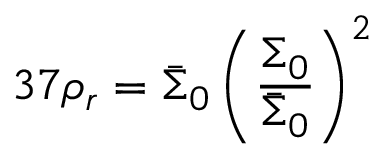Convert formula to latex. <formula><loc_0><loc_0><loc_500><loc_500>3 7 \rho _ { r } = \bar { \Sigma } _ { 0 } \left ( \frac { \Sigma _ { 0 } } { \bar { \Sigma } _ { 0 } } \right ) ^ { 2 }</formula> 